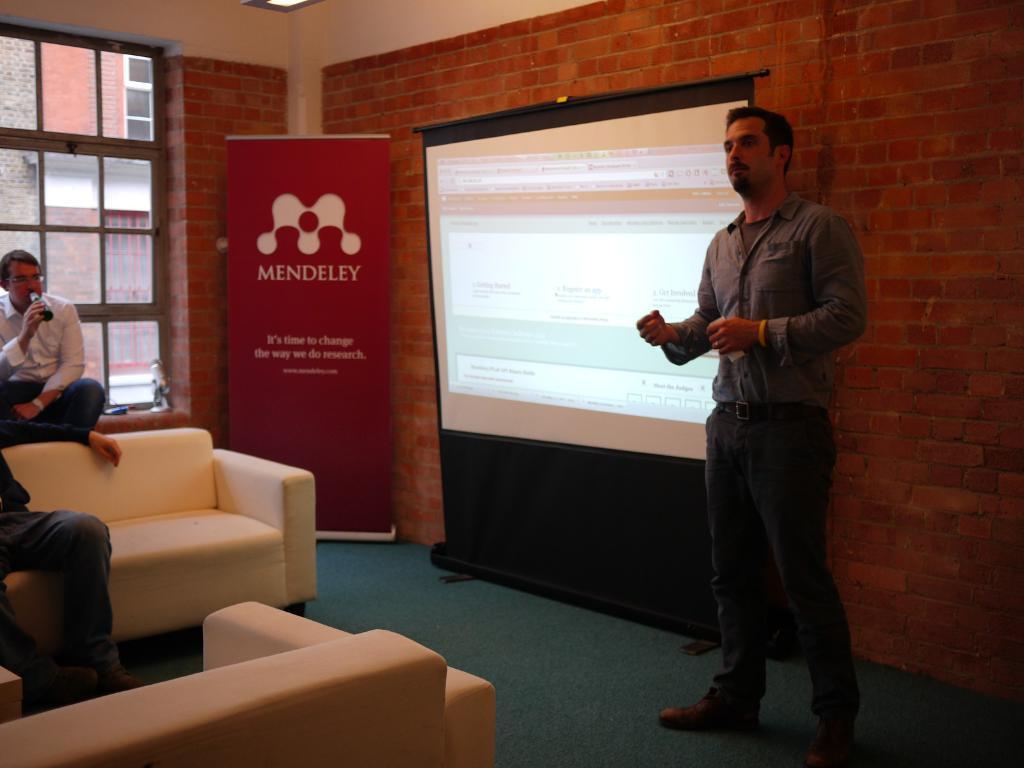Please provide a concise description of this image. This picture is taken during a presentation in a room on the left there is a person standing. In the center of the picture there is a screen. In the background there is a brick wall. On the right there are couches. On the left there is a person sitting. On the top left there is a window. In the center there is a hoarding. 